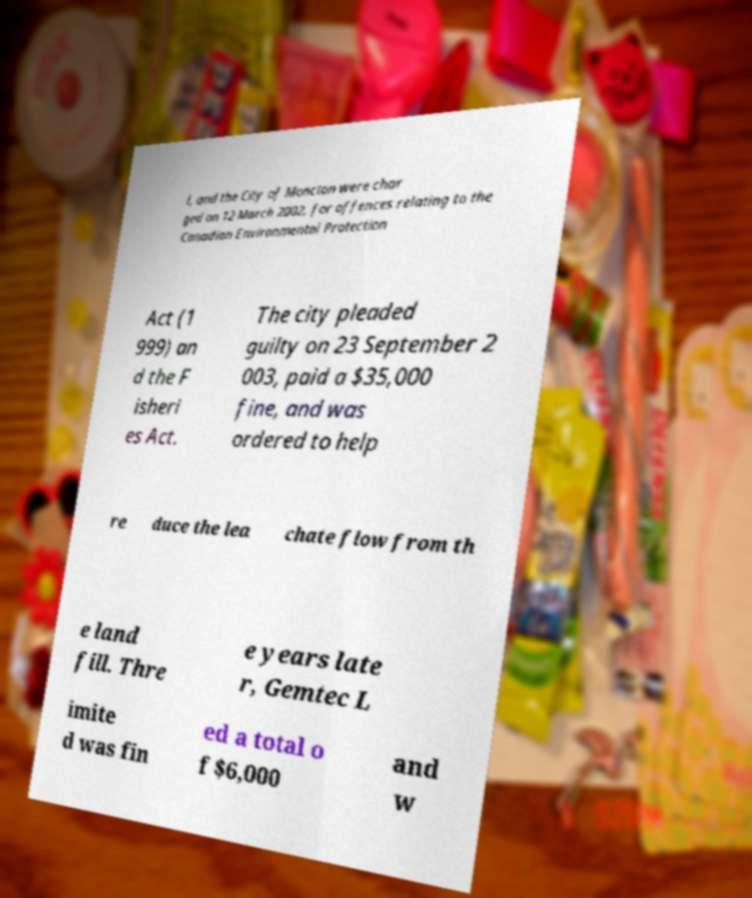Can you accurately transcribe the text from the provided image for me? l, and the City of Moncton were char ged on 12 March 2002, for offences relating to the Canadian Environmental Protection Act (1 999) an d the F isheri es Act. The city pleaded guilty on 23 September 2 003, paid a $35,000 fine, and was ordered to help re duce the lea chate flow from th e land fill. Thre e years late r, Gemtec L imite d was fin ed a total o f $6,000 and w 